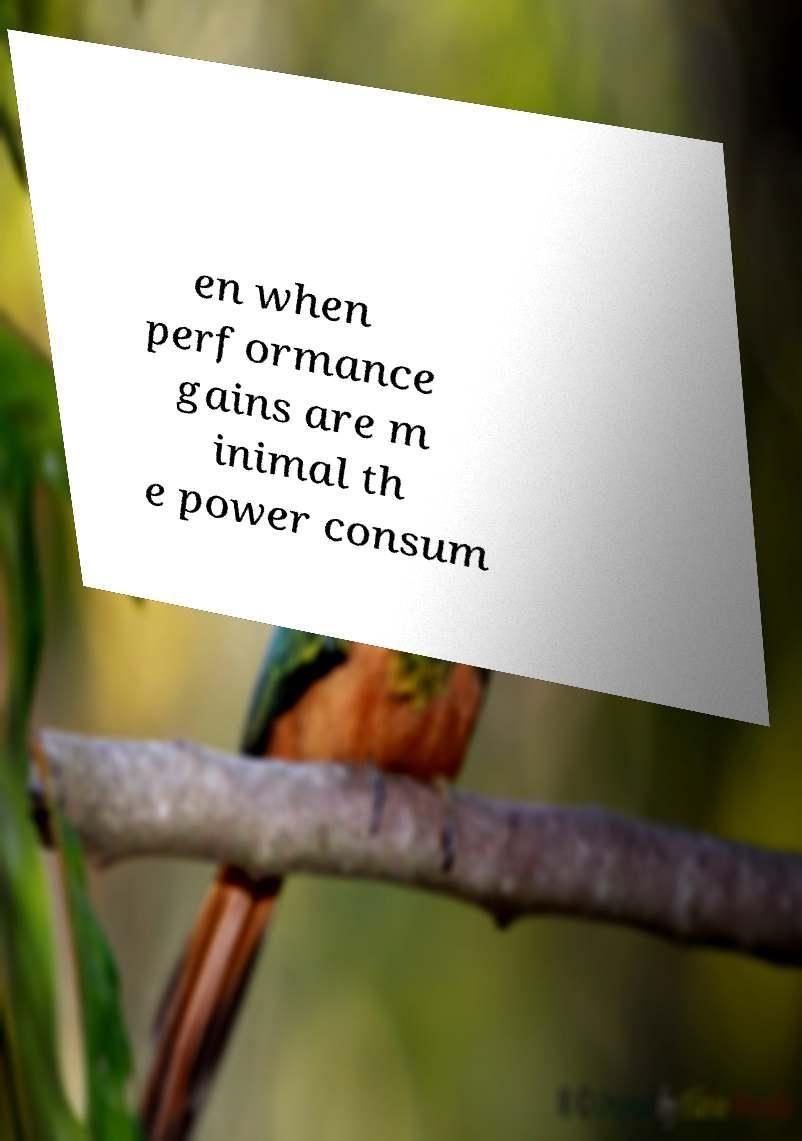There's text embedded in this image that I need extracted. Can you transcribe it verbatim? en when performance gains are m inimal th e power consum 